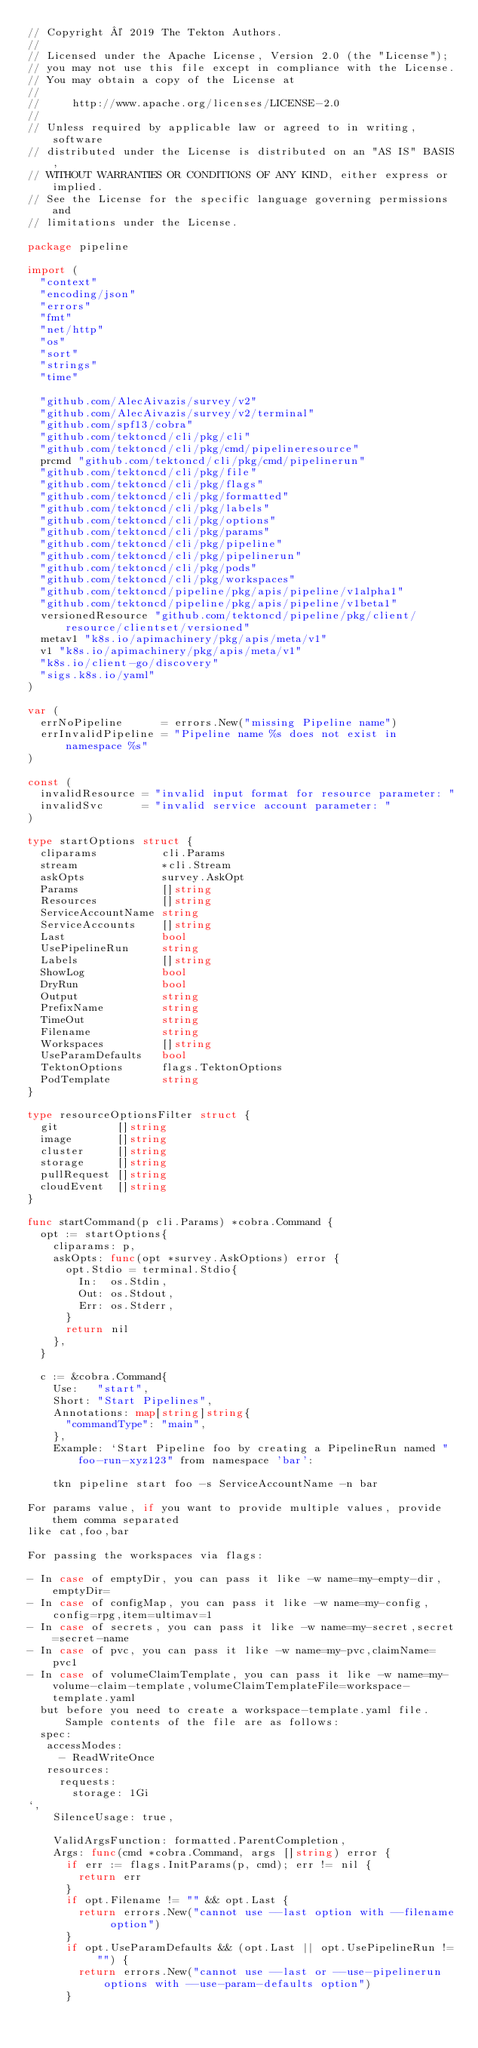<code> <loc_0><loc_0><loc_500><loc_500><_Go_>// Copyright © 2019 The Tekton Authors.
//
// Licensed under the Apache License, Version 2.0 (the "License");
// you may not use this file except in compliance with the License.
// You may obtain a copy of the License at
//
//     http://www.apache.org/licenses/LICENSE-2.0
//
// Unless required by applicable law or agreed to in writing, software
// distributed under the License is distributed on an "AS IS" BASIS,
// WITHOUT WARRANTIES OR CONDITIONS OF ANY KIND, either express or implied.
// See the License for the specific language governing permissions and
// limitations under the License.

package pipeline

import (
	"context"
	"encoding/json"
	"errors"
	"fmt"
	"net/http"
	"os"
	"sort"
	"strings"
	"time"

	"github.com/AlecAivazis/survey/v2"
	"github.com/AlecAivazis/survey/v2/terminal"
	"github.com/spf13/cobra"
	"github.com/tektoncd/cli/pkg/cli"
	"github.com/tektoncd/cli/pkg/cmd/pipelineresource"
	prcmd "github.com/tektoncd/cli/pkg/cmd/pipelinerun"
	"github.com/tektoncd/cli/pkg/file"
	"github.com/tektoncd/cli/pkg/flags"
	"github.com/tektoncd/cli/pkg/formatted"
	"github.com/tektoncd/cli/pkg/labels"
	"github.com/tektoncd/cli/pkg/options"
	"github.com/tektoncd/cli/pkg/params"
	"github.com/tektoncd/cli/pkg/pipeline"
	"github.com/tektoncd/cli/pkg/pipelinerun"
	"github.com/tektoncd/cli/pkg/pods"
	"github.com/tektoncd/cli/pkg/workspaces"
	"github.com/tektoncd/pipeline/pkg/apis/pipeline/v1alpha1"
	"github.com/tektoncd/pipeline/pkg/apis/pipeline/v1beta1"
	versionedResource "github.com/tektoncd/pipeline/pkg/client/resource/clientset/versioned"
	metav1 "k8s.io/apimachinery/pkg/apis/meta/v1"
	v1 "k8s.io/apimachinery/pkg/apis/meta/v1"
	"k8s.io/client-go/discovery"
	"sigs.k8s.io/yaml"
)

var (
	errNoPipeline      = errors.New("missing Pipeline name")
	errInvalidPipeline = "Pipeline name %s does not exist in namespace %s"
)

const (
	invalidResource = "invalid input format for resource parameter: "
	invalidSvc      = "invalid service account parameter: "
)

type startOptions struct {
	cliparams          cli.Params
	stream             *cli.Stream
	askOpts            survey.AskOpt
	Params             []string
	Resources          []string
	ServiceAccountName string
	ServiceAccounts    []string
	Last               bool
	UsePipelineRun     string
	Labels             []string
	ShowLog            bool
	DryRun             bool
	Output             string
	PrefixName         string
	TimeOut            string
	Filename           string
	Workspaces         []string
	UseParamDefaults   bool
	TektonOptions      flags.TektonOptions
	PodTemplate        string
}

type resourceOptionsFilter struct {
	git         []string
	image       []string
	cluster     []string
	storage     []string
	pullRequest []string
	cloudEvent  []string
}

func startCommand(p cli.Params) *cobra.Command {
	opt := startOptions{
		cliparams: p,
		askOpts: func(opt *survey.AskOptions) error {
			opt.Stdio = terminal.Stdio{
				In:  os.Stdin,
				Out: os.Stdout,
				Err: os.Stderr,
			}
			return nil
		},
	}

	c := &cobra.Command{
		Use:   "start",
		Short: "Start Pipelines",
		Annotations: map[string]string{
			"commandType": "main",
		},
		Example: `Start Pipeline foo by creating a PipelineRun named "foo-run-xyz123" from namespace 'bar':

    tkn pipeline start foo -s ServiceAccountName -n bar

For params value, if you want to provide multiple values, provide them comma separated
like cat,foo,bar

For passing the workspaces via flags:

- In case of emptyDir, you can pass it like -w name=my-empty-dir,emptyDir=
- In case of configMap, you can pass it like -w name=my-config,config=rpg,item=ultimav=1
- In case of secrets, you can pass it like -w name=my-secret,secret=secret-name
- In case of pvc, you can pass it like -w name=my-pvc,claimName=pvc1
- In case of volumeClaimTemplate, you can pass it like -w name=my-volume-claim-template,volumeClaimTemplateFile=workspace-template.yaml
  but before you need to create a workspace-template.yaml file. Sample contents of the file are as follows:
  spec:
   accessModes:
     - ReadWriteOnce
   resources:
     requests:
       storage: 1Gi
`,
		SilenceUsage: true,

		ValidArgsFunction: formatted.ParentCompletion,
		Args: func(cmd *cobra.Command, args []string) error {
			if err := flags.InitParams(p, cmd); err != nil {
				return err
			}
			if opt.Filename != "" && opt.Last {
				return errors.New("cannot use --last option with --filename option")
			}
			if opt.UseParamDefaults && (opt.Last || opt.UsePipelineRun != "") {
				return errors.New("cannot use --last or --use-pipelinerun options with --use-param-defaults option")
			}</code> 